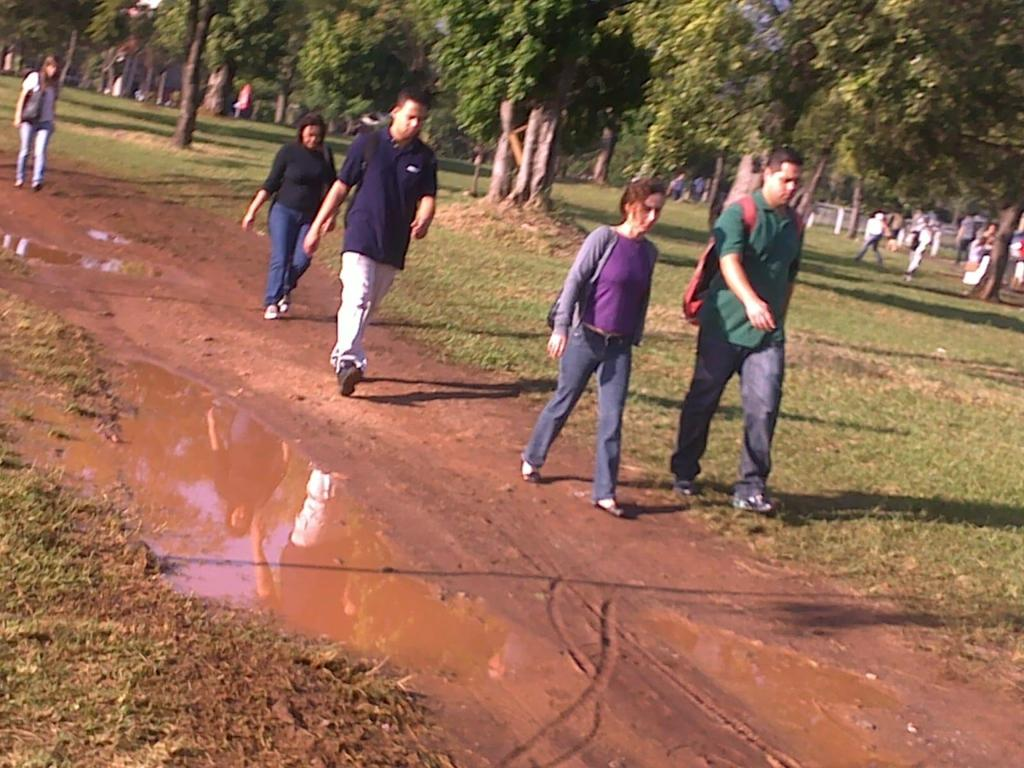What are the people in the image doing? The people in the image are walking on the ground. What can be seen in the background of the image? There is water, grass, and trees visible in the image. What else is present on the ground in the image? There are other objects on the ground in the image. What type of glove is being used to set off the alarm in the image? There is no glove or alarm present in the image. How much milk can be seen in the image? There is no milk present in the image. 